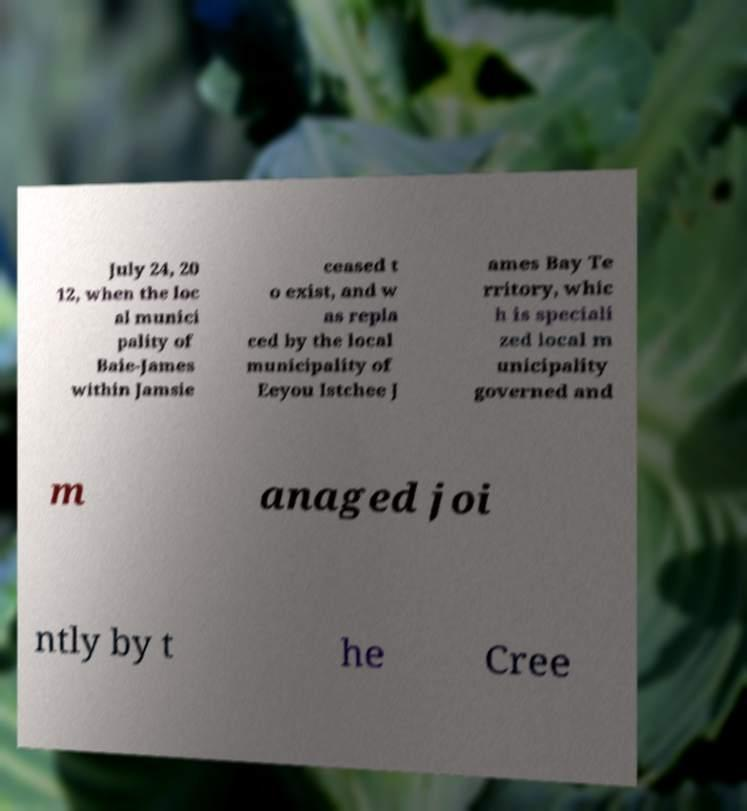Please read and relay the text visible in this image. What does it say? July 24, 20 12, when the loc al munici pality of Baie-James within Jamsie ceased t o exist, and w as repla ced by the local municipality of Eeyou Istchee J ames Bay Te rritory, whic h is speciali zed local m unicipality governed and m anaged joi ntly by t he Cree 